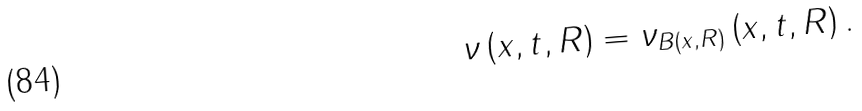Convert formula to latex. <formula><loc_0><loc_0><loc_500><loc_500>\nu \left ( x , t , R \right ) = \nu _ { B \left ( x , R \right ) } \left ( x , t , R \right ) .</formula> 